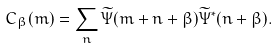Convert formula to latex. <formula><loc_0><loc_0><loc_500><loc_500>C _ { \beta } ( m ) = \sum _ { n } \widetilde { \Psi } ( m + n + \beta ) \widetilde { \Psi } ^ { \ast } ( n + \beta ) .</formula> 